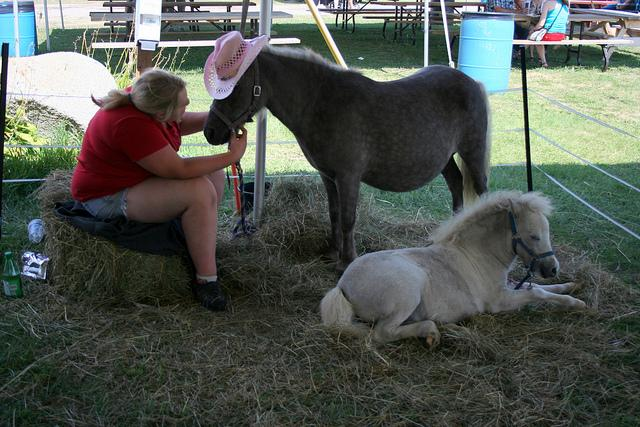The woman is putting what piece of her safety riding gear on the pony? Please explain your reasoning. harness. The woman is putting a harness on the mouth of the horse. 